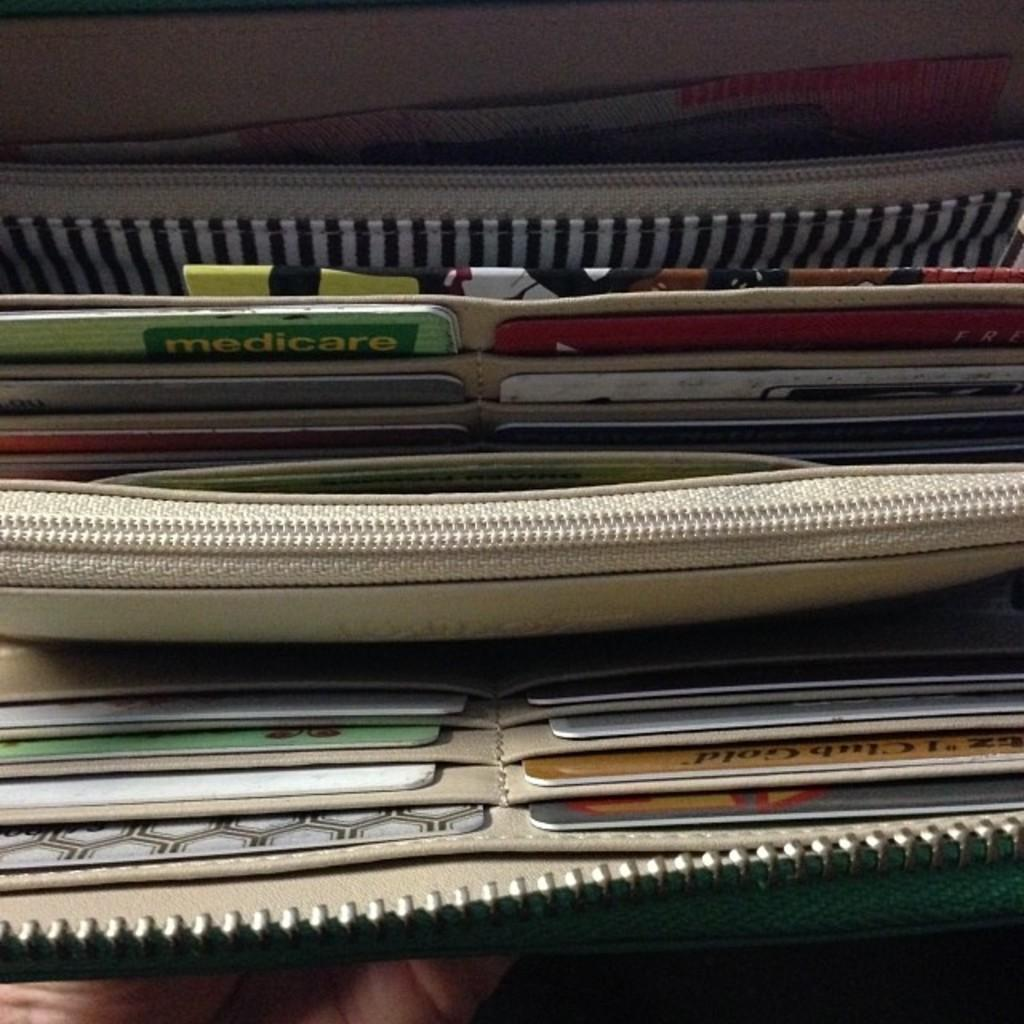What items can be found in the wallet in the image? There are different types of cards, zips, and currency in the wallet. How is the wallet secured? The wallet has zips to secure its contents. What type of currency is present in the wallet? The currency in the wallet is not specified, but it is mentioned that there is currency present. Whose hand is visible at the bottom of the image? A person's hand is visible at the bottom of the image, but their identity is not mentioned. What type of linen is used to make the wallet in the image? The type of linen used to make the wallet is not mentioned in the image. How many apples are visible in the image? There are no apples visible in the image; it only features a wallet and a person's hand. 